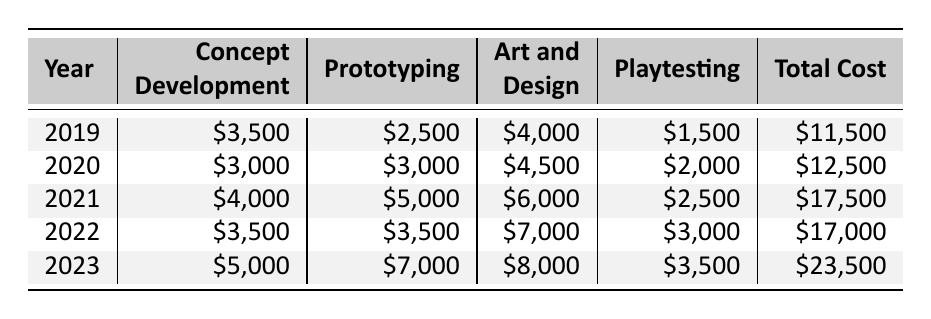What was the total cost for board game development in 2021? Referring to the table, the total cost for board game development in 2021 is listed in the "Total Cost" column, which shows \$17,500.
Answer: \$17,500 In which year did the concept development cost increase the most compared to the previous year? By examining the concept development costs for each year, the increase is from \$3,500 in 2019 to \$4,000 in 2021 (an increase of \$500) and from \$3,000 in 2020 to \$4,000 in 2021 (an increase of \$1,000), which is the largest increase.
Answer: 2021 What is the average art and design cost over the five years? The art and design costs are \$4,000, \$4,500, \$6,000, \$7,000, and \$8,000. Summing these gives a total of \$29,500. Dividing this by the number of years (5) provides an average of \$5,900.
Answer: \$5,900 Did the total cost ever decrease from one year to the next? By checking the total costs year by year: \$11,500 (2019), \$12,500 (2020), \$17,500 (2021), \$17,000 (2022), and \$23,500 (2023), we see a decrease from \$17,500 to \$17,000 from 2021 to 2022.
Answer: Yes What was the increase in total cost from 2020 to 2023? The total cost in 2020 is \$12,500 and in 2023 it is \$23,500. The increase can be calculated by subtracting these two values: \$23,500 - \$12,500 = \$11,000.
Answer: \$11,000 Which year had the highest cost for prototyping, and what was that cost? Looking at the prototyping costs for each year, the highest value is \$7,000 in 2023.
Answer: 2023, \$7,000 What was the total cost for all years combined? Summing the total costs: \$11,500 + \$12,500 + \$17,500 + \$17,000 + \$23,500 equals a total of \$81,000.
Answer: \$81,000 How much higher was the playtesting cost in 2023 compared to 2019? The playtesting cost in 2023 is \$3,500, while in 2019 it was \$1,500. The difference can be calculated as \$3,500 - \$1,500 = \$2,000.
Answer: \$2,000 Was the total cost greater than \$20,000 in any year? Checking the total costs: \$11,500, \$12,500, \$17,500, \$17,000, and \$23,500, we find that it exceeded \$20,000 only in 2023, which is \$23,500.
Answer: Yes What percentage of the total cost in 2022 was allocated to art and design? In 2022, the total cost is \$17,000 and art and design cost is \$7,000. Calculating the percentage: (\$7,000 / \$17,000) * 100 = approximately 41.18%.
Answer: 41.18% 